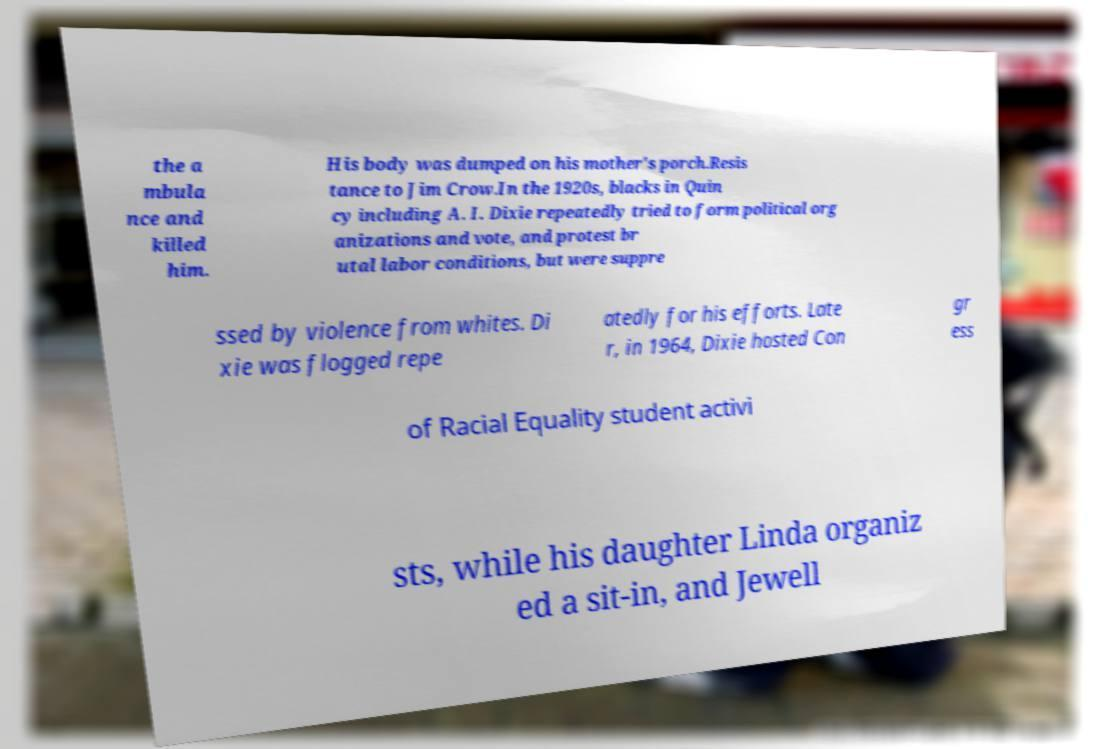Could you extract and type out the text from this image? the a mbula nce and killed him. His body was dumped on his mother's porch.Resis tance to Jim Crow.In the 1920s, blacks in Quin cy including A. I. Dixie repeatedly tried to form political org anizations and vote, and protest br utal labor conditions, but were suppre ssed by violence from whites. Di xie was flogged repe atedly for his efforts. Late r, in 1964, Dixie hosted Con gr ess of Racial Equality student activi sts, while his daughter Linda organiz ed a sit-in, and Jewell 